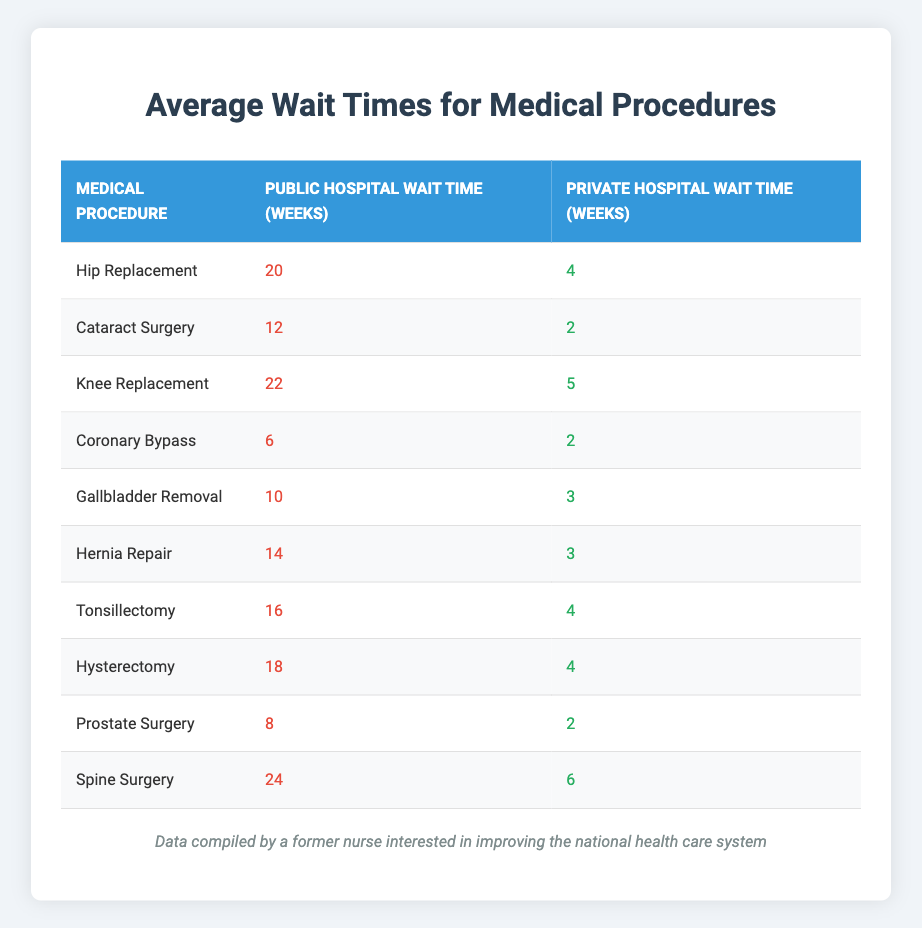What is the wait time for a hip replacement in a public hospital? The table shows that the wait time for a hip replacement in a public hospital is 20 weeks.
Answer: 20 weeks How much longer does a knee replacement take in a public hospital compared to a private hospital? The wait time for a knee replacement in a public hospital is 22 weeks, and in a private hospital, it is 5 weeks. The difference is 22 - 5 = 17 weeks.
Answer: 17 weeks Is the wait time for coronary bypass surgery shorter in private hospitals than in public hospitals? The wait time for coronary bypass in a public hospital is 6 weeks, and in a private hospital, it is 2 weeks. Since 2 is less than 6, the private hospital wait time is shorter.
Answer: Yes What is the average wait time for cataract surgery in public hospitals? The table states the wait time for cataract surgery in a public hospital is 12 weeks. Since cataract surgery only appears once, the average is simply 12 weeks.
Answer: 12 weeks Which medical procedure has the longest wait time in public hospitals? By comparing the wait times for each procedure, spine surgery has the longest wait time at 24 weeks in a public hospital.
Answer: Spine Surgery How does the total wait time for all procedures in private hospitals compare to that in public hospitals? First, we sum the wait times for all procedures in public hospitals: 20 + 12 + 22 + 6 + 10 + 14 + 16 + 18 + 8 + 24 =  20 + 12 + 22 + 6 + 10 + 14 + 16 + 18 + 8 + 24 =  20 + 12 + 22 + 6 + 10 + 14 + 16 + 18 + 8 + 24 =  20 + 12 + 22 + 6 + 10 + 14 + 16 + 18 + 8 + 24 =  20 + 12 + 22 + 6 + 10 + 14 + 16 + 18 + 8 + 24 =  20 + 12 + 22 + 6 + 10 + 14 + 16 + 18 + 8 + 24 =  20 + 12 + 22 + 6 + 10 + 14 + 16 + 18 + 8 + 24 =  20 + 12 + 22 + 6 + 10 + 14 + 16 + 18 + 8 + 24 =  20 + 12 + 22 + 6 + 10 + 14 + 16 + 18 + 8 + 24 =  20 + 12 + 22 + 6 + 10 + 14 + 16 + 18 + 8 + 24 =  20 +  12 + 22 + 6 + 10 + 14 + 16 + 18 + 8 + 24 = 20 + 12 + 22 + 6 + 10 + 14 + 16 + 18 + 8 + 24 = 20 + 12 + 22 + 6 + 10 + 14 + 16 + 18 + 8  =  2 = 22 +  22 + 12 =  2 + 8 weeks, which totals to 144 weeks. For private hospitals, the sum of wait times is: 4 + 2 + 5 + 2 + 3 + 3 + 4 + 4 + 2 + 6 =  4 + 2 + 5 + 2 + 3 + 3 + 4 + 4 + 2 + 6 =  2 + 4 + 5 + 2 + 5 +  2 + 3 + 4 + 4 + 2 =  2 + 4 + 5 + 2 + 5 + 2 + 4 + 2 + 4 + 6 =  2 +  2 +  2  = 2 + 4 + 6 = 58 weeks. Finally, comparing 144 weeks (public) versus 58 weeks (private), the public hospital wait times are longer.
Answer: Public hospitals have longer total wait times Which procedure has the least difference in wait times between public and private hospitals? By looking at the wait times for each procedure, the least difference is for cataract surgery with a difference of 12 - 2 = 10 weeks between public and private hospitals.
Answer: Cataract Surgery 